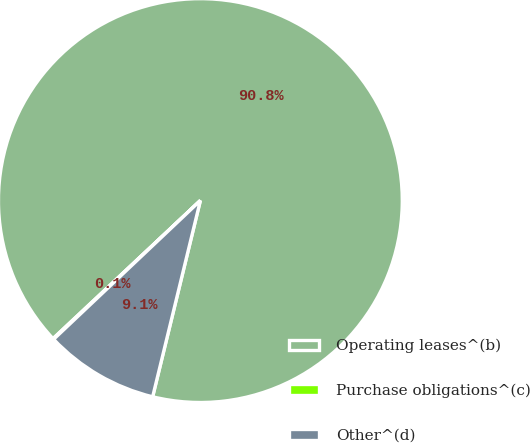Convert chart. <chart><loc_0><loc_0><loc_500><loc_500><pie_chart><fcel>Operating leases^(b)<fcel>Purchase obligations^(c)<fcel>Other^(d)<nl><fcel>90.78%<fcel>0.07%<fcel>9.15%<nl></chart> 